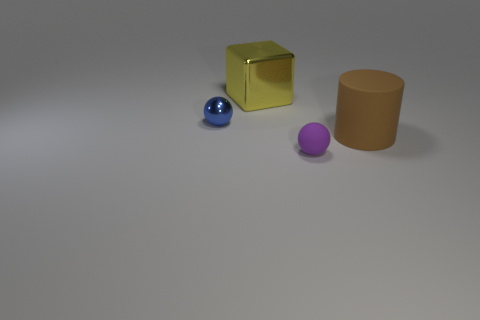Add 2 tiny blue objects. How many objects exist? 6 Subtract all cylinders. How many objects are left? 3 Subtract 1 purple spheres. How many objects are left? 3 Subtract all large green matte objects. Subtract all large yellow blocks. How many objects are left? 3 Add 3 brown rubber cylinders. How many brown rubber cylinders are left? 4 Add 3 matte cylinders. How many matte cylinders exist? 4 